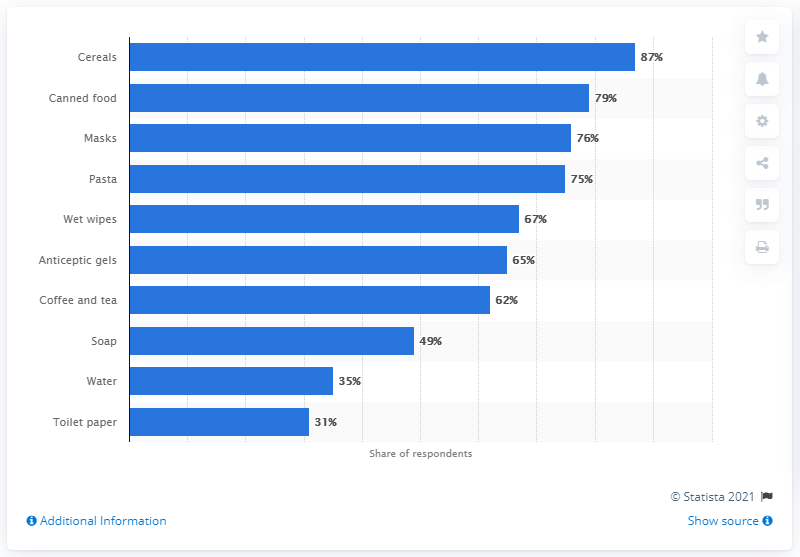Give some essential details in this illustration. During the COVID-19 pandemic, a significant percentage of Russians purchased cereals, with 87% reporting that they had purchased these products. During the COVID-19 pandemic, Russians have reportedly stocked up on cereals as their most popular food product. The chart includes five types of foods. The most popular product in the chart is cereals. 